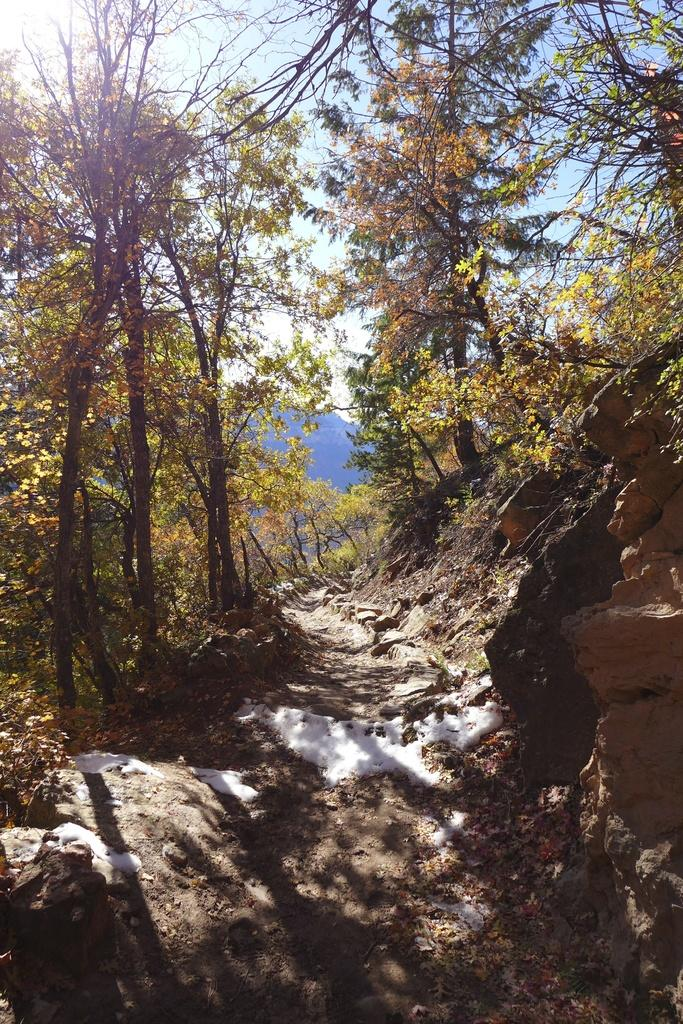What type of vegetation can be seen in the image? There are trees in the image. What is present on the ground beneath the trees? Dried leaves are present on the ground in the image. What part of the natural environment is visible in the image? The sky is visible in the image. What type of fuel is being used by the woman playing on the playground in the image? There is no woman or playground present in the image, so it is not possible to determine what type of fuel might be used. 